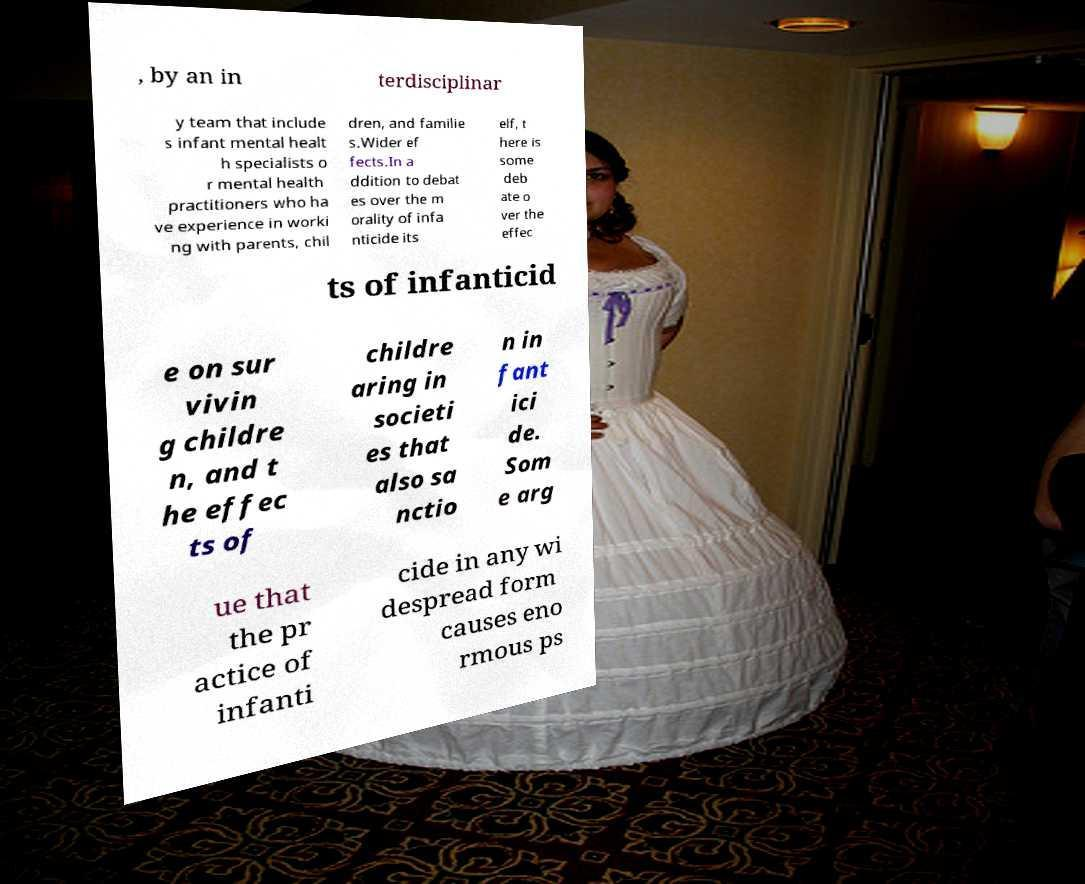Could you extract and type out the text from this image? , by an in terdisciplinar y team that include s infant mental healt h specialists o r mental health practitioners who ha ve experience in worki ng with parents, chil dren, and familie s.Wider ef fects.In a ddition to debat es over the m orality of infa nticide its elf, t here is some deb ate o ver the effec ts of infanticid e on sur vivin g childre n, and t he effec ts of childre aring in societi es that also sa nctio n in fant ici de. Som e arg ue that the pr actice of infanti cide in any wi despread form causes eno rmous ps 